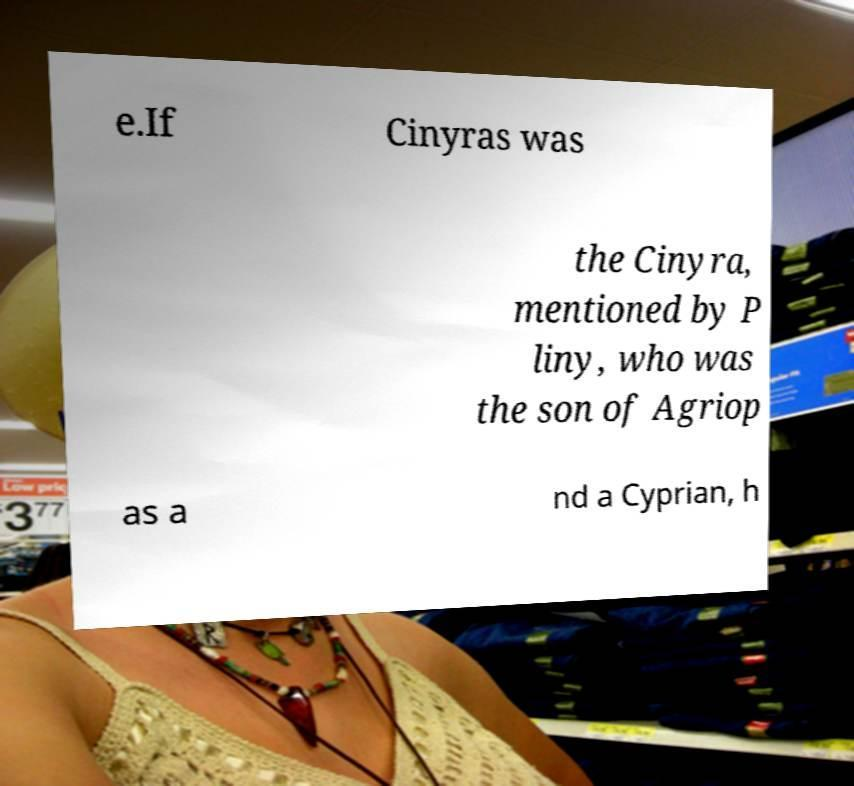For documentation purposes, I need the text within this image transcribed. Could you provide that? e.If Cinyras was the Cinyra, mentioned by P liny, who was the son of Agriop as a nd a Cyprian, h 